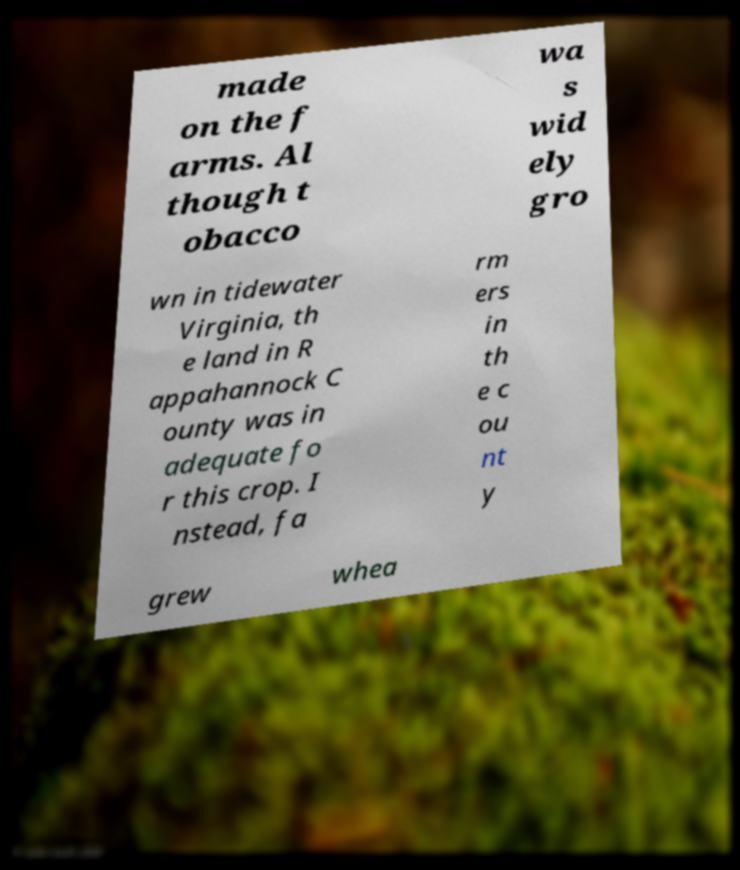Please identify and transcribe the text found in this image. made on the f arms. Al though t obacco wa s wid ely gro wn in tidewater Virginia, th e land in R appahannock C ounty was in adequate fo r this crop. I nstead, fa rm ers in th e c ou nt y grew whea 